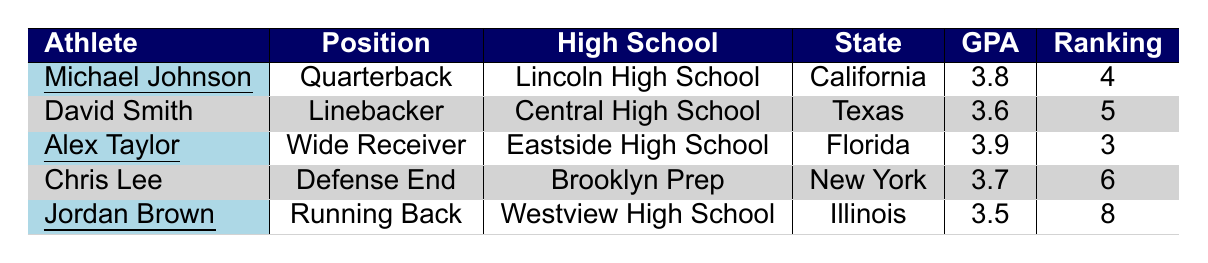What is the highest GPA among the athletes? The GPAs of the athletes are 3.8 (Michael Johnson), 3.6 (David Smith), 3.9 (Alex Taylor), 3.7 (Chris Lee), and 3.5 (Jordan Brown). The highest value is 3.9.
Answer: 3.9 Which athlete received offers from University of Florida? Alex Taylor is the athlete that received scholarship offers, which include University of Florida.
Answer: Alex Taylor How many offers did Jordan Brown receive? Jordan Brown received three offers: University of Illinois, Northwestern University, and University of Notre Dame. Counting these gives us three.
Answer: 3 Is David Smith's ranking lower than 5? David Smith has a ranking of 5, so his ranking is not lower than 5. This statement is false.
Answer: No What is the average GPA of the listed athletes? The GPAs are 3.8, 3.6, 3.9, 3.7, and 3.5. Summing these gives us 18.5, and dividing by 5 gives an average of 3.7.
Answer: 3.7 Which athlete from Florida has the highest ranking? Alex Taylor from Florida has a ranking of 3. Since only one athlete from Florida is listed, he has the highest ranking in that state.
Answer: Alex Taylor How many athletes are from California? There is only one athlete, Michael Johnson, listed from California in the data. So the total is one.
Answer: 1 Are there any athletes with a GPA higher than 3.6? Michael Johnson (3.8), Alex Taylor (3.9), and Chris Lee (3.7) have GPAs higher than 3.6. Therefore, the answer is yes.
Answer: Yes Which athlete has the lowest ranking and what is their GPA? Jordan Brown has the lowest ranking at 8, and their GPA is 3.5.
Answer: Jordan Brown, 3.5 What is the difference in ranking between Michael Johnson and Chris Lee? Michael Johnson has a ranking of 4, and Chris Lee has a ranking of 6. The difference is 6 - 4 = 2.
Answer: 2 